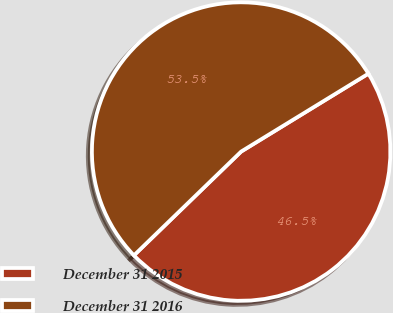Convert chart to OTSL. <chart><loc_0><loc_0><loc_500><loc_500><pie_chart><fcel>December 31 2015<fcel>December 31 2016<nl><fcel>46.5%<fcel>53.5%<nl></chart> 